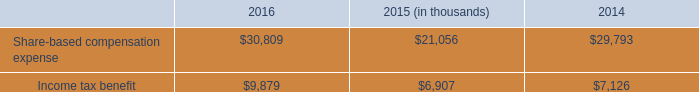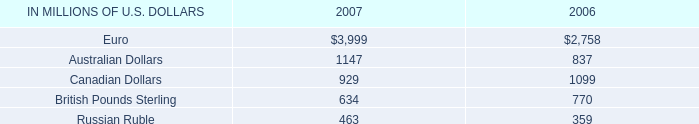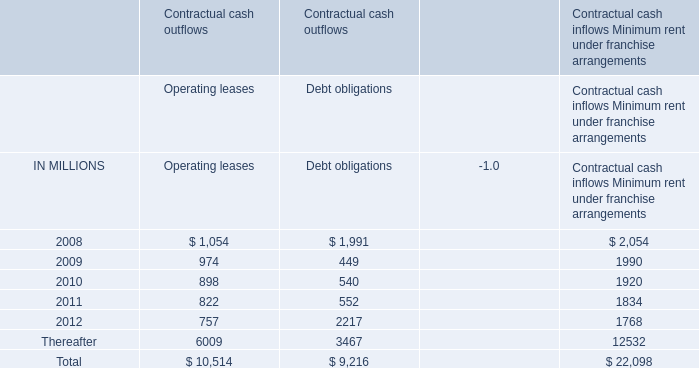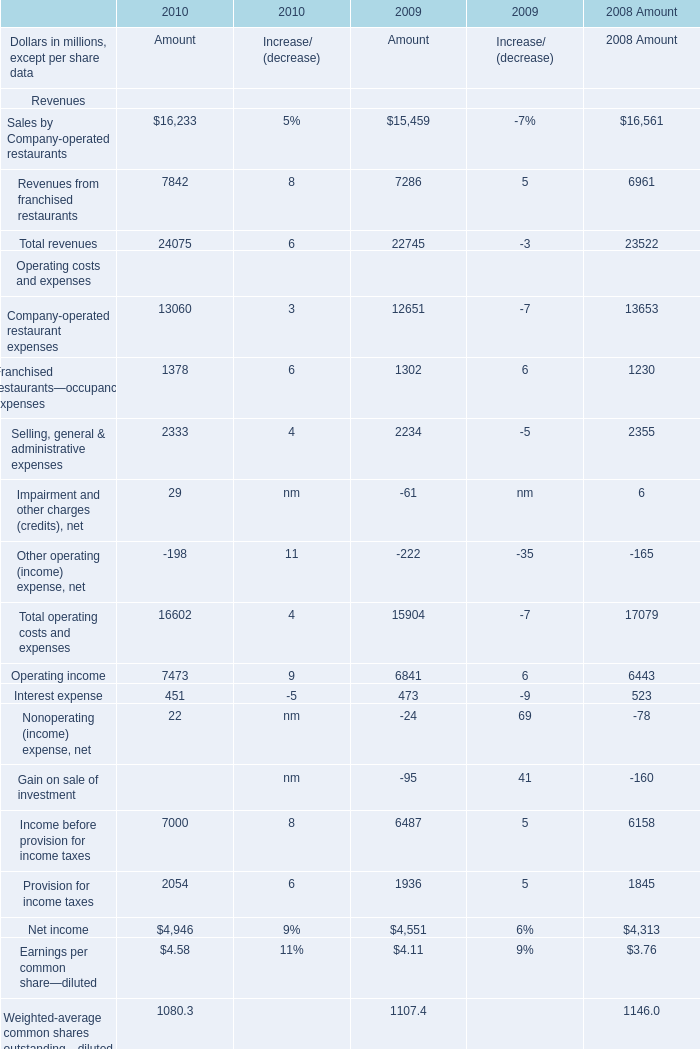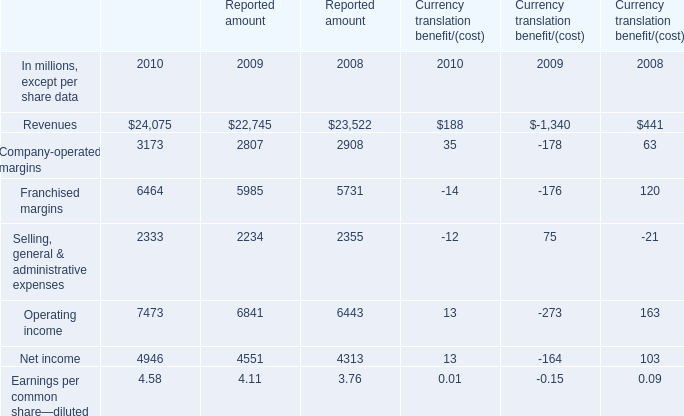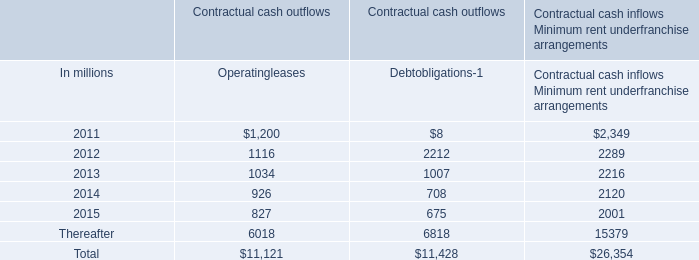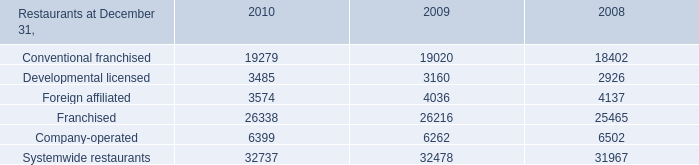Which year is Interest expense for Amount the least? 
Answer: 2010. 